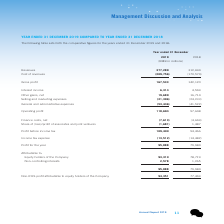Looking at Tencent's financial data, please calculate: What was the 2019 profit margin? Based on the calculation: 95,888/377,289, the result is 25.42 (percentage). This is based on the information: "Profit for the year 95,888 79,984 Revenues 377,289 312,694..." The key data points involved are: 377,289, 95,888. Also, can you calculate: What was the 2018 profit margin? Based on the calculation: 79,984/312,694, the result is 25.58 (percentage). This is based on the information: "Revenues 377,289 312,694 Profit for the year 95,888 79,984..." The key data points involved are: 312,694, 79,984. Also, can you calculate: For 2019, what percentage of revenue is cost of revenue? Based on the calculation: 209,756/377,289, the result is 55.6 (percentage). This is based on the information: "Cost of revenues (209,756) (170,574) Revenues 377,289 312,694..." The key data points involved are: 209,756, 377,289. Also, What is the 2019 percentage change in selling & marketing expenses? Based on the financial document, the answer is 12%. Also, What was the reason for the 2019 year-on-year percentage change in selling and marketing expenses? Based on the financial document, the answer is The decrease was mainly due to the reduction of advertising and promotion expenses as a result of improved operational efficiencies.. Also, What was the reason behind the increase in the 2019 general and administrative expenses? Based on the financial document, the answer is The increase was primarily driven by greater R&D expenses and staff costs.. 